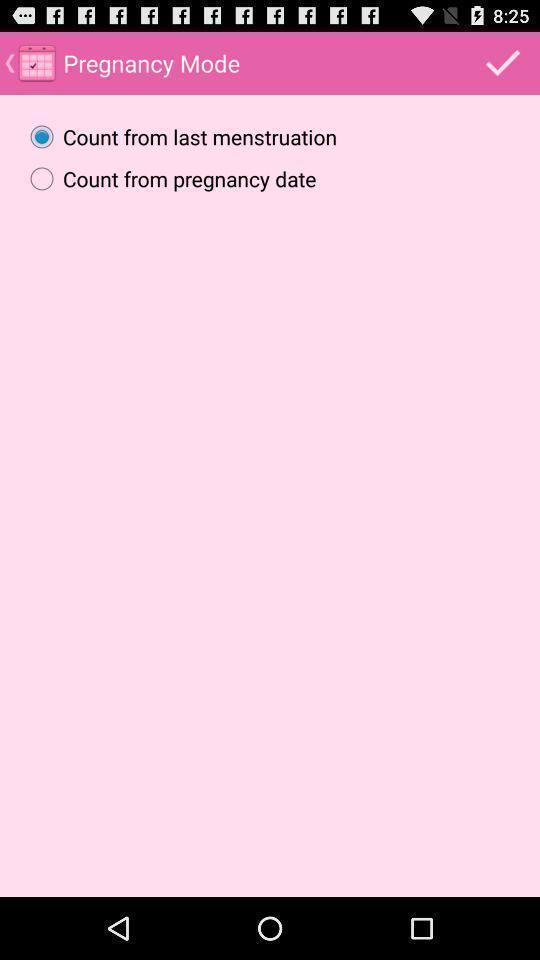Summarize the main components in this picture. Screen shows pregnancy mode. 